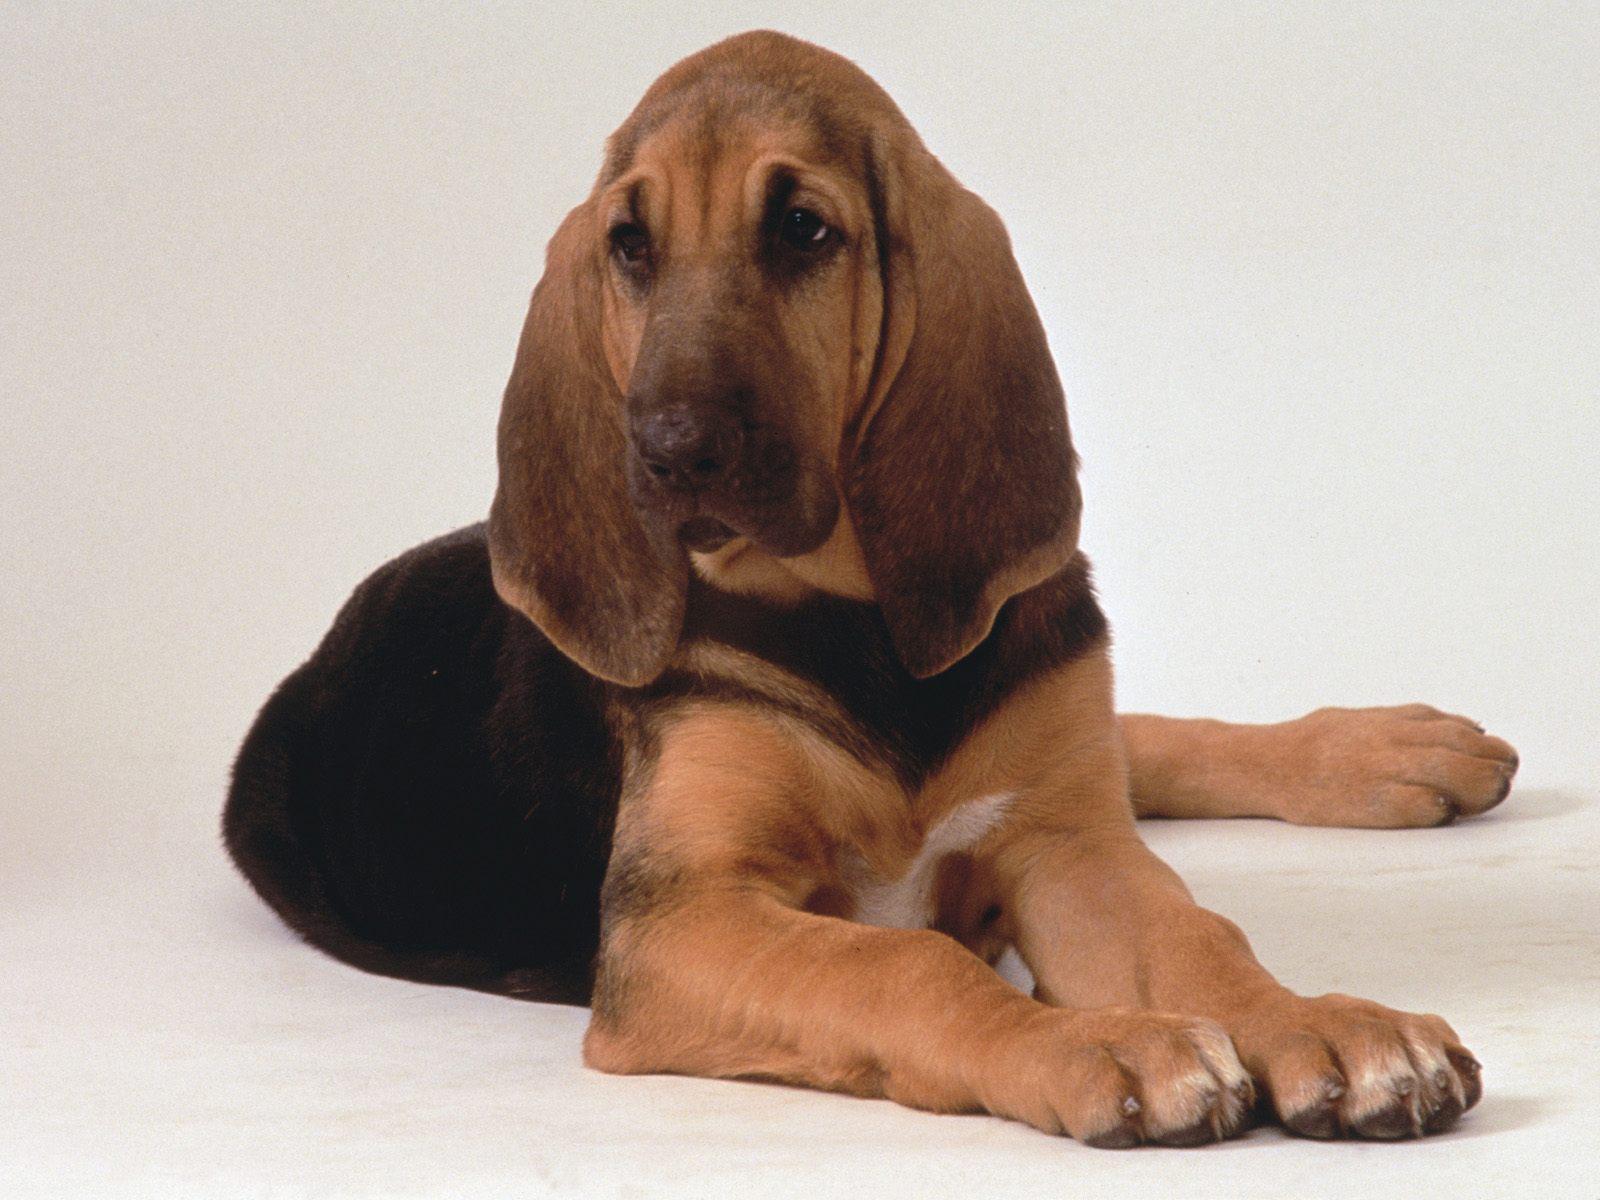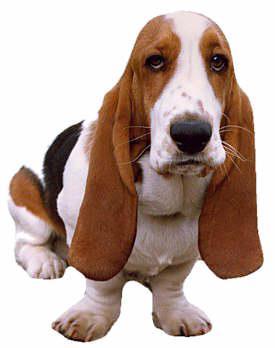The first image is the image on the left, the second image is the image on the right. Considering the images on both sides, is "There are two dogs in total." valid? Answer yes or no. Yes. 